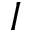<formula> <loc_0><loc_0><loc_500><loc_500>I</formula> 